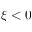<formula> <loc_0><loc_0><loc_500><loc_500>\xi < 0</formula> 